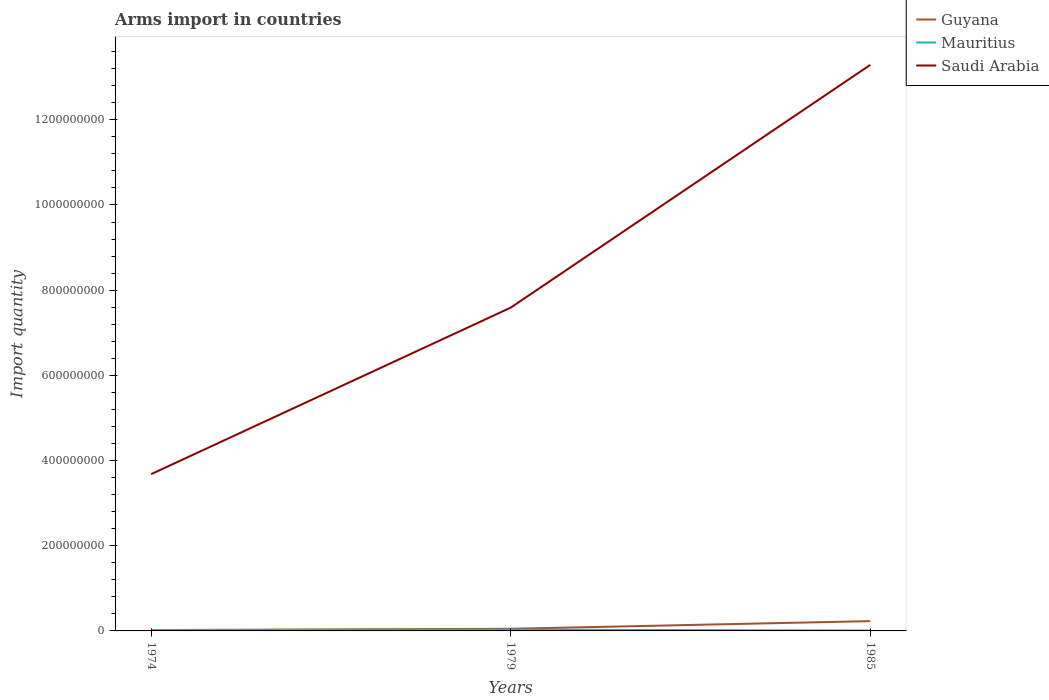How many different coloured lines are there?
Offer a very short reply. 3. Does the line corresponding to Saudi Arabia intersect with the line corresponding to Guyana?
Your answer should be compact. No. What is the difference between the highest and the second highest total arms import in Guyana?
Your response must be concise. 2.10e+07. What is the difference between the highest and the lowest total arms import in Mauritius?
Your response must be concise. 1. Is the total arms import in Mauritius strictly greater than the total arms import in Saudi Arabia over the years?
Keep it short and to the point. Yes. Are the values on the major ticks of Y-axis written in scientific E-notation?
Offer a very short reply. No. Does the graph contain any zero values?
Ensure brevity in your answer.  No. Does the graph contain grids?
Your answer should be very brief. No. Where does the legend appear in the graph?
Provide a succinct answer. Top right. How many legend labels are there?
Your response must be concise. 3. How are the legend labels stacked?
Offer a terse response. Vertical. What is the title of the graph?
Provide a succinct answer. Arms import in countries. What is the label or title of the Y-axis?
Give a very brief answer. Import quantity. What is the Import quantity in Mauritius in 1974?
Your answer should be very brief. 2.00e+06. What is the Import quantity in Saudi Arabia in 1974?
Your answer should be very brief. 3.68e+08. What is the Import quantity of Guyana in 1979?
Keep it short and to the point. 5.00e+06. What is the Import quantity of Saudi Arabia in 1979?
Your response must be concise. 7.59e+08. What is the Import quantity of Guyana in 1985?
Offer a terse response. 2.30e+07. What is the Import quantity of Mauritius in 1985?
Offer a very short reply. 1.00e+06. What is the Import quantity in Saudi Arabia in 1985?
Provide a succinct answer. 1.33e+09. Across all years, what is the maximum Import quantity in Guyana?
Your response must be concise. 2.30e+07. Across all years, what is the maximum Import quantity in Mauritius?
Provide a short and direct response. 3.00e+06. Across all years, what is the maximum Import quantity of Saudi Arabia?
Your response must be concise. 1.33e+09. Across all years, what is the minimum Import quantity in Guyana?
Provide a short and direct response. 2.00e+06. Across all years, what is the minimum Import quantity in Saudi Arabia?
Make the answer very short. 3.68e+08. What is the total Import quantity in Guyana in the graph?
Give a very brief answer. 3.00e+07. What is the total Import quantity of Saudi Arabia in the graph?
Ensure brevity in your answer.  2.46e+09. What is the difference between the Import quantity of Saudi Arabia in 1974 and that in 1979?
Give a very brief answer. -3.91e+08. What is the difference between the Import quantity of Guyana in 1974 and that in 1985?
Make the answer very short. -2.10e+07. What is the difference between the Import quantity in Saudi Arabia in 1974 and that in 1985?
Offer a very short reply. -9.61e+08. What is the difference between the Import quantity of Guyana in 1979 and that in 1985?
Your answer should be very brief. -1.80e+07. What is the difference between the Import quantity in Saudi Arabia in 1979 and that in 1985?
Your answer should be very brief. -5.70e+08. What is the difference between the Import quantity in Guyana in 1974 and the Import quantity in Saudi Arabia in 1979?
Your response must be concise. -7.57e+08. What is the difference between the Import quantity of Mauritius in 1974 and the Import quantity of Saudi Arabia in 1979?
Offer a terse response. -7.57e+08. What is the difference between the Import quantity of Guyana in 1974 and the Import quantity of Saudi Arabia in 1985?
Provide a succinct answer. -1.33e+09. What is the difference between the Import quantity in Mauritius in 1974 and the Import quantity in Saudi Arabia in 1985?
Make the answer very short. -1.33e+09. What is the difference between the Import quantity in Guyana in 1979 and the Import quantity in Saudi Arabia in 1985?
Provide a short and direct response. -1.32e+09. What is the difference between the Import quantity in Mauritius in 1979 and the Import quantity in Saudi Arabia in 1985?
Provide a short and direct response. -1.33e+09. What is the average Import quantity in Guyana per year?
Give a very brief answer. 1.00e+07. What is the average Import quantity in Saudi Arabia per year?
Provide a succinct answer. 8.19e+08. In the year 1974, what is the difference between the Import quantity of Guyana and Import quantity of Mauritius?
Provide a short and direct response. 0. In the year 1974, what is the difference between the Import quantity in Guyana and Import quantity in Saudi Arabia?
Ensure brevity in your answer.  -3.66e+08. In the year 1974, what is the difference between the Import quantity in Mauritius and Import quantity in Saudi Arabia?
Your answer should be compact. -3.66e+08. In the year 1979, what is the difference between the Import quantity of Guyana and Import quantity of Saudi Arabia?
Provide a short and direct response. -7.54e+08. In the year 1979, what is the difference between the Import quantity in Mauritius and Import quantity in Saudi Arabia?
Ensure brevity in your answer.  -7.56e+08. In the year 1985, what is the difference between the Import quantity in Guyana and Import quantity in Mauritius?
Give a very brief answer. 2.20e+07. In the year 1985, what is the difference between the Import quantity of Guyana and Import quantity of Saudi Arabia?
Your answer should be compact. -1.31e+09. In the year 1985, what is the difference between the Import quantity of Mauritius and Import quantity of Saudi Arabia?
Your answer should be compact. -1.33e+09. What is the ratio of the Import quantity in Guyana in 1974 to that in 1979?
Ensure brevity in your answer.  0.4. What is the ratio of the Import quantity of Mauritius in 1974 to that in 1979?
Keep it short and to the point. 0.67. What is the ratio of the Import quantity of Saudi Arabia in 1974 to that in 1979?
Give a very brief answer. 0.48. What is the ratio of the Import quantity in Guyana in 1974 to that in 1985?
Ensure brevity in your answer.  0.09. What is the ratio of the Import quantity of Saudi Arabia in 1974 to that in 1985?
Ensure brevity in your answer.  0.28. What is the ratio of the Import quantity of Guyana in 1979 to that in 1985?
Provide a succinct answer. 0.22. What is the ratio of the Import quantity of Saudi Arabia in 1979 to that in 1985?
Provide a succinct answer. 0.57. What is the difference between the highest and the second highest Import quantity in Guyana?
Ensure brevity in your answer.  1.80e+07. What is the difference between the highest and the second highest Import quantity of Saudi Arabia?
Offer a very short reply. 5.70e+08. What is the difference between the highest and the lowest Import quantity in Guyana?
Your response must be concise. 2.10e+07. What is the difference between the highest and the lowest Import quantity in Saudi Arabia?
Provide a succinct answer. 9.61e+08. 